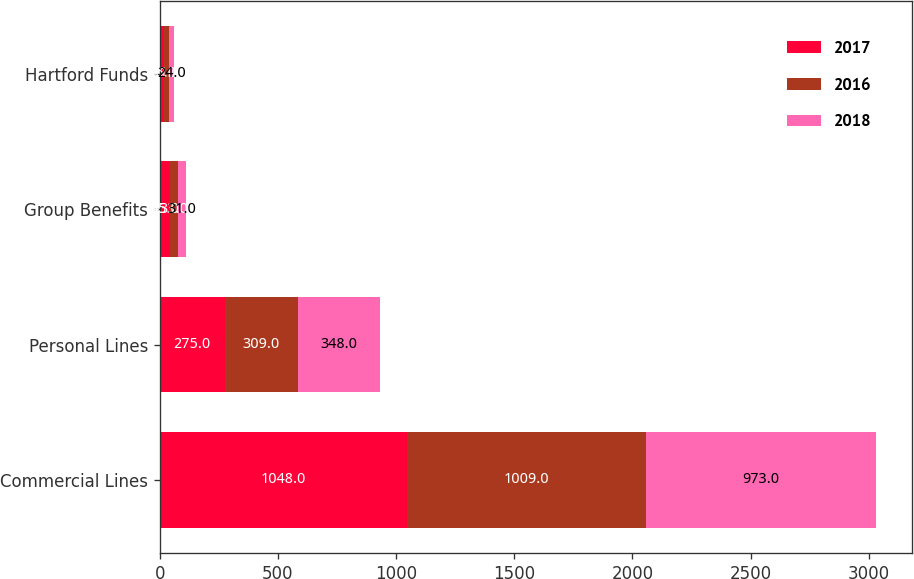Convert chart to OTSL. <chart><loc_0><loc_0><loc_500><loc_500><stacked_bar_chart><ecel><fcel>Commercial Lines<fcel>Personal Lines<fcel>Group Benefits<fcel>Hartford Funds<nl><fcel>2017<fcel>1048<fcel>275<fcel>45<fcel>16<nl><fcel>2016<fcel>1009<fcel>309<fcel>33<fcel>21<nl><fcel>2018<fcel>973<fcel>348<fcel>31<fcel>24<nl></chart> 